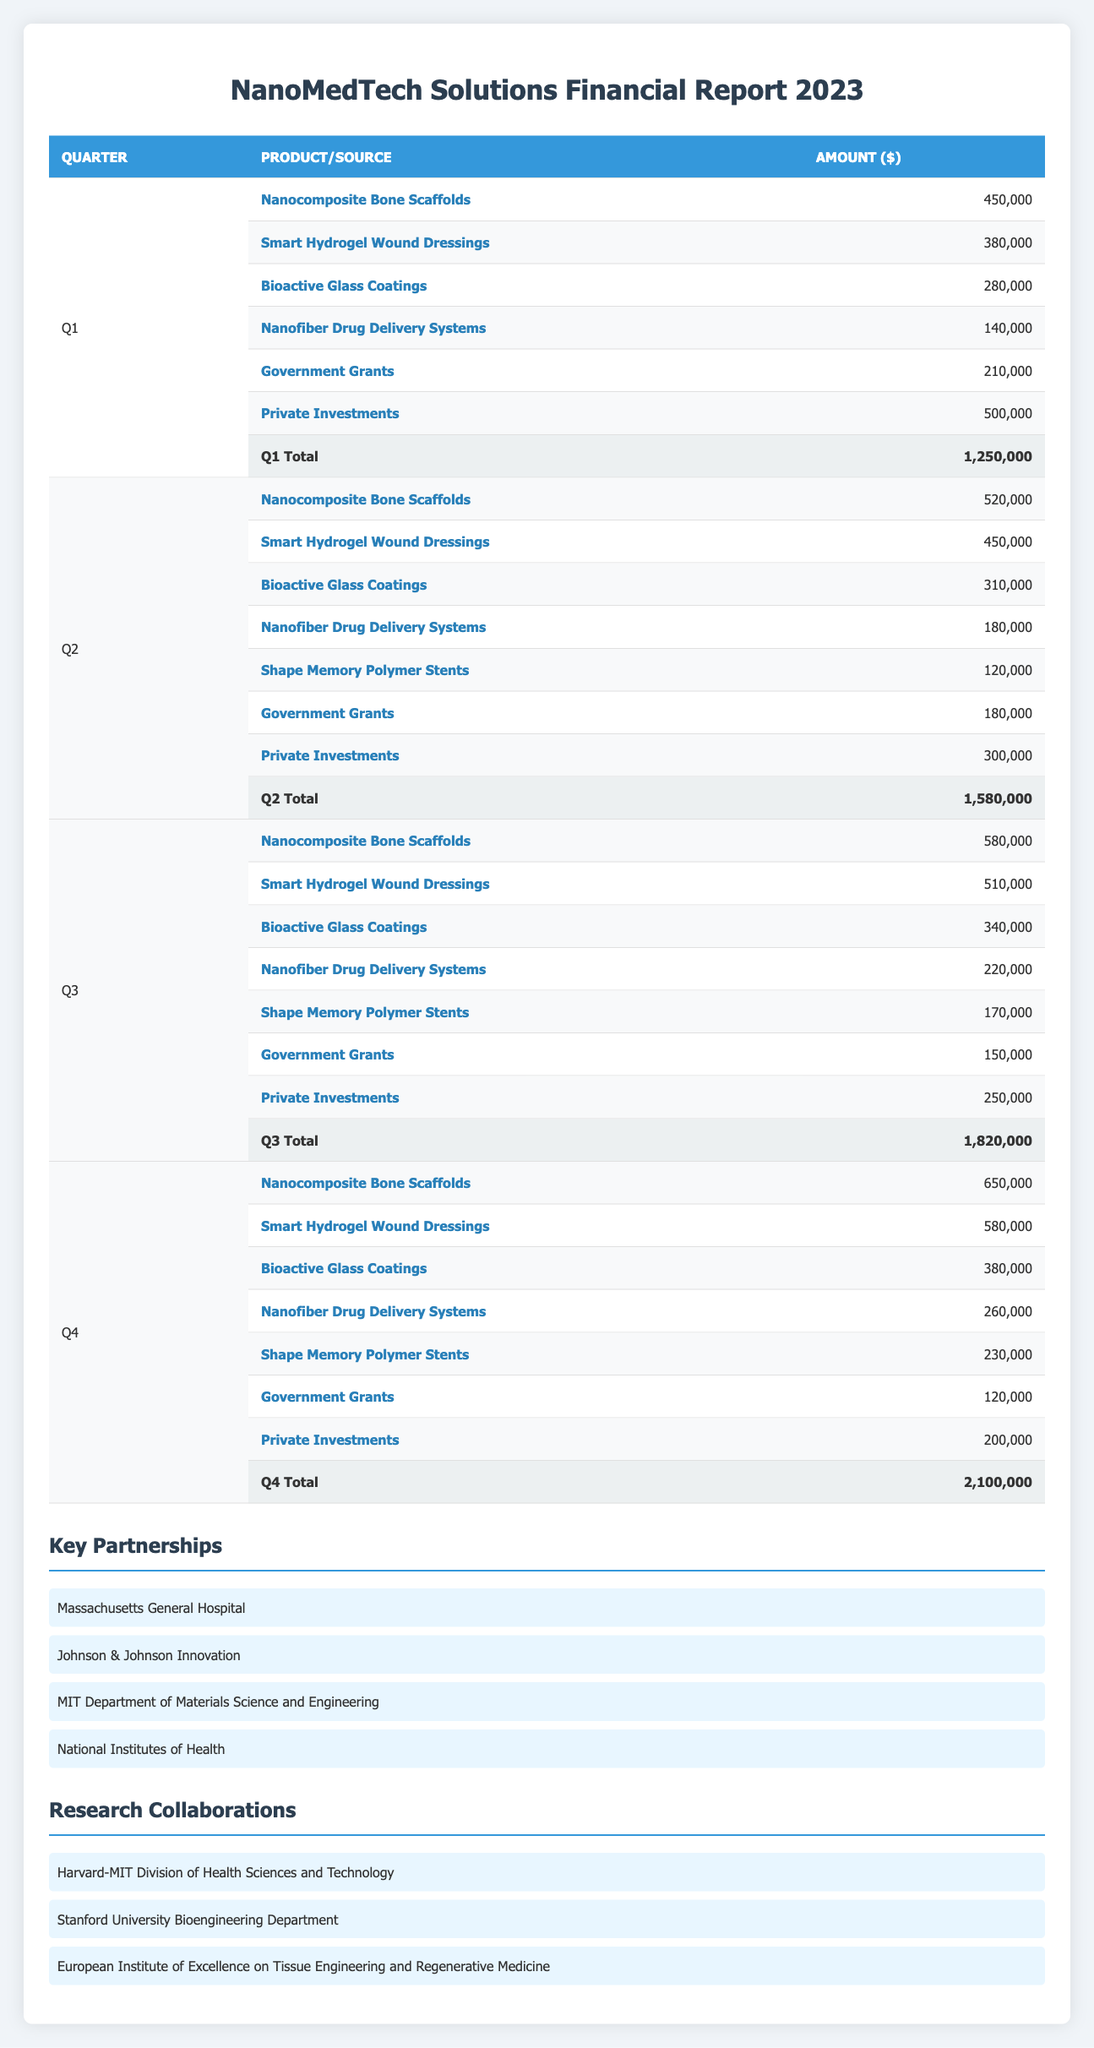What was the total revenue for Q3? The total revenue for Q3 is listed in the table under "Q3 Total" and is shown as 1,820,000.
Answer: 1,820,000 Which product generated the highest revenue in Q4? In Q4, the "Nanocomposite Bone Scaffolds" had the highest amount listed at 650,000, more than any other product in that quarter.
Answer: Nanocomposite Bone Scaffolds What is the total revenue from government grants throughout 2023? The government grants for each quarter are: Q1: 210,000, Q2: 180,000, Q3: 150,000, and Q4: 120,000. Adding these gives: 210,000 + 180,000 + 150,000 + 120,000 = 660,000.
Answer: 660,000 Did private investments increase from Q1 to Q4? The private investments for each quarter are Q1: 500,000 and Q4: 200,000. Since 200,000 is less than 500,000, the private investments did not increase.
Answer: No What was the percentage increase in total revenue from Q2 to Q3? The total revenue for Q2 is 1,580,000 and for Q3 is 1,820,000. The increase is calculated as (1,820,000 - 1,580,000) / 1,580,000 * 100, which equals 15.25%.
Answer: 15.25% Which quarter had the lowest revenue from "Smart Hydrogel Wound Dressings"? The "Smart Hydrogel Wound Dressings" generated 380,000 in Q1, 450,000 in Q2, 510,000 in Q3, and 580,000 in Q4. Thus, Q1 had the lowest revenue.
Answer: Q1 What is the average revenue from "Shape Memory Polymer Stents" over the four quarters? The amounts for "Shape Memory Polymer Stents" are Q2: 120,000, Q3: 170,000, and Q4: 230,000. They were not sold in Q1 (0). So, the average is (0 + 120,000 + 170,000 + 230,000) / 4 = 130,000.
Answer: 130,000 Is the total revenue for Q4 the highest of all four quarters? The total revenues for all quarters are: Q1: 1,250,000, Q2: 1,580,000, Q3: 1,820,000, and Q4: 2,100,000. Since 2,100,000 is greater than the others, it is indeed the highest.
Answer: Yes 